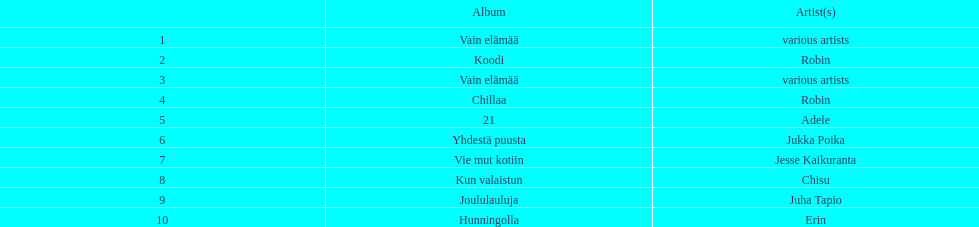Which was better selling, hunningolla or vain elamaa? Vain elämää. 